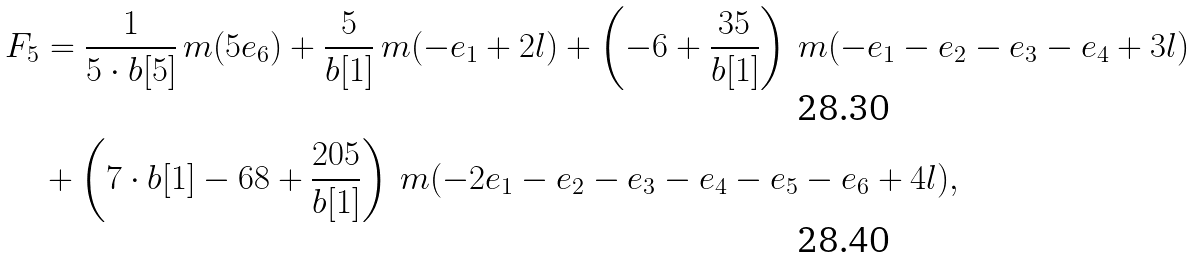<formula> <loc_0><loc_0><loc_500><loc_500>F _ { 5 } & = \frac { 1 } { 5 \cdot b [ 5 ] } \, m ( 5 e _ { 6 } ) + \frac { 5 } { b [ 1 ] } \, m ( - e _ { 1 } + 2 l ) + \left ( - 6 + \frac { 3 5 } { b [ 1 ] } \right ) \, m ( - e _ { 1 } - e _ { 2 } - e _ { 3 } - e _ { 4 } + 3 l ) \\ & + \left ( 7 \cdot b [ 1 ] - 6 8 + \frac { 2 0 5 } { b [ 1 ] } \right ) \, m ( - 2 e _ { 1 } - e _ { 2 } - e _ { 3 } - e _ { 4 } - e _ { 5 } - e _ { 6 } + 4 l ) ,</formula> 